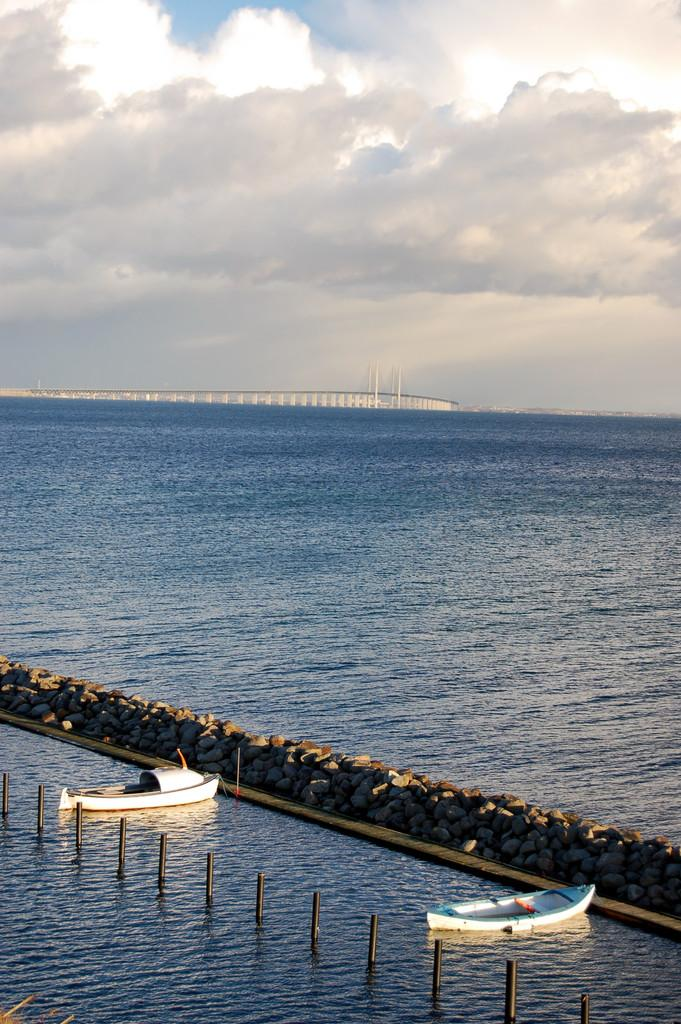What is the main subject in the center of the image? There are boats in the center of the image. Where are the boats located? The boats are on the water. What can be seen in the background of the image? There is an ocean and a bridge in the background of the image. How would you describe the sky in the image? The sky is cloudy. What type of cats are being taught to mine coal in the image? There are no cats or coal mining activities present in the image. 